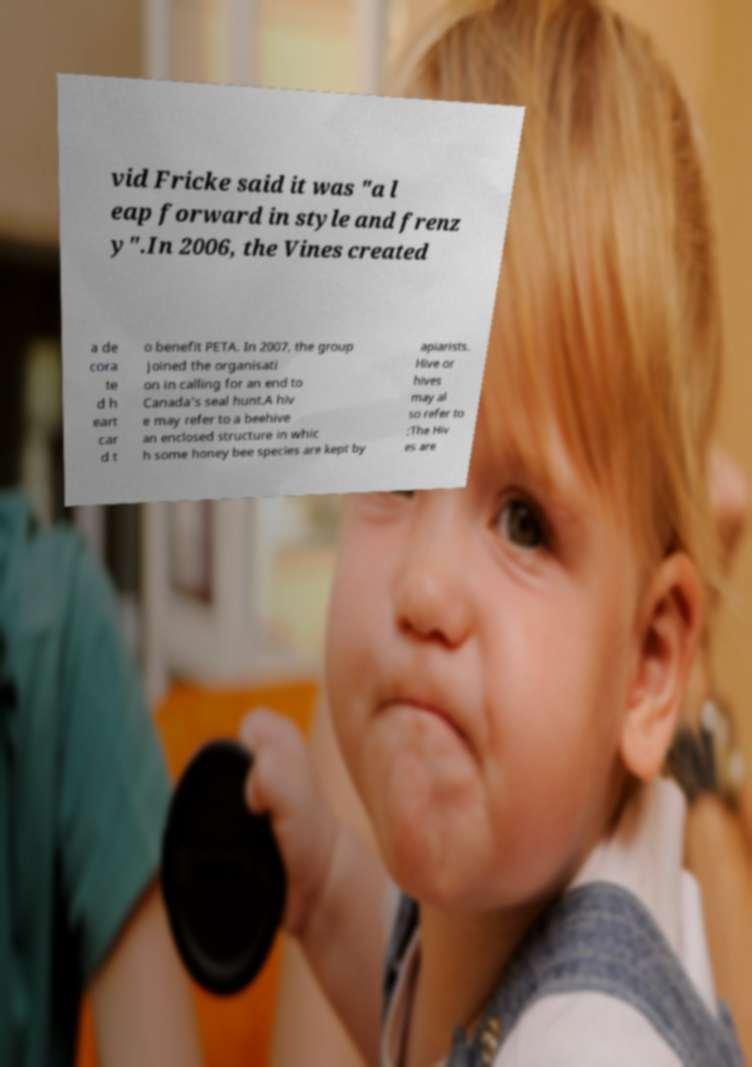For documentation purposes, I need the text within this image transcribed. Could you provide that? vid Fricke said it was "a l eap forward in style and frenz y".In 2006, the Vines created a de cora te d h eart car d t o benefit PETA. In 2007, the group joined the organisati on in calling for an end to Canada's seal hunt.A hiv e may refer to a beehive an enclosed structure in whic h some honey bee species are kept by apiarists. Hive or hives may al so refer to :The Hiv es are 